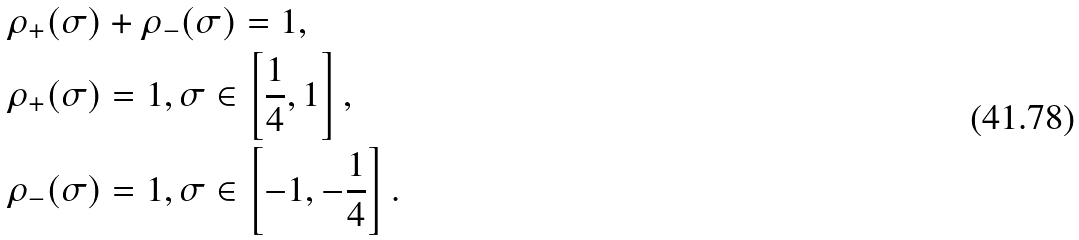Convert formula to latex. <formula><loc_0><loc_0><loc_500><loc_500>& \rho _ { + } ( \sigma ) + \rho _ { - } ( \sigma ) = 1 , \\ & \rho _ { + } ( \sigma ) = 1 , \sigma \in \left [ \frac { 1 } { 4 } , 1 \right ] , \\ & \rho _ { - } ( \sigma ) = 1 , \sigma \in \left [ - 1 , - \frac { 1 } { 4 } \right ] .</formula> 